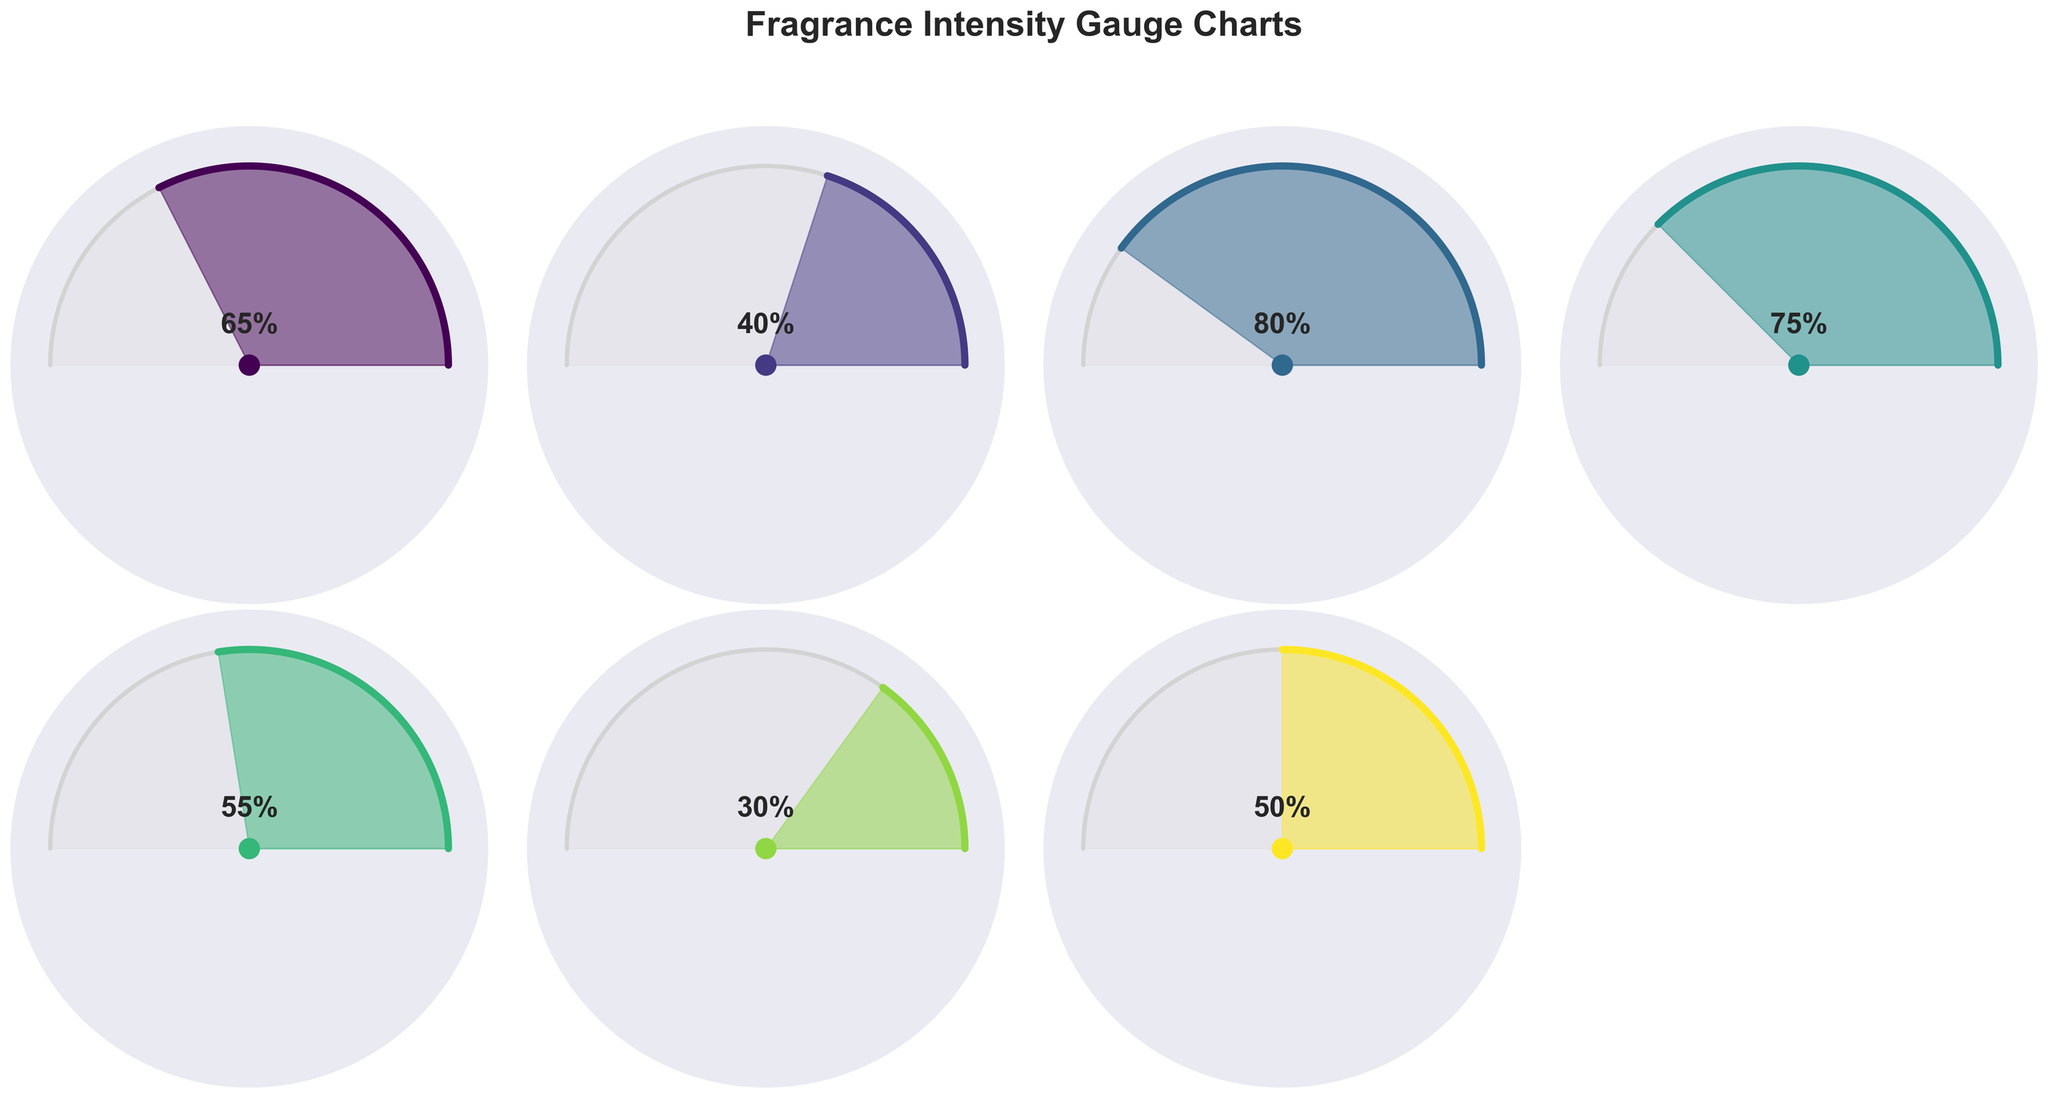What's the title of the figure? Look at the top of the figure to find the main title that summarizes the content.
Answer: Fragrance Intensity Gauge Charts Which fragrance has the highest intensity value? Compare the intensity percentage written on all the gauge charts to find the highest value.
Answer: Jasmine Which fragrance has the lowest intensity value? Compare the intensity percentage displayed on all the gauge charts to find the lowest value.
Answer: Orchid How many fragrances are presented in the figure? Count the number of gauge charts representing different fragrances.
Answer: 7 What is the difference between the highest and lowest fragrance intensities? Subtract the lowest intensity value (Orchid, 30%) from the highest intensity value (Jasmine, 80%).
Answer: 50% What's the average intensity value of all the fragrances? Sum all the intensity values (65 + 40 + 80 + 75 + 55 + 30 + 50 = 395) and divide by the number of fragrances (7).
Answer: 56.43% Which fragrance has an intensity closest to the average intensity of all fragrances? Identify the fragrance whose intensity is closest to the calculated average (56.43%). Compare each fragrance's intensity to this value.
Answer: Lily Arrange the fragrances in descending order of their intensity values. List the fragrances from the highest intensity to the lowest based on the intensity percentages.
Answer: Jasmine, Gardenia, Rose, Lily, Peony, Lavender, Orchid Does any fragrance have an intensity exactly at 50%? Check each fragrance's intensity value to see if any is exactly 50%.
Answer: Yes, Peony 